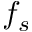<formula> <loc_0><loc_0><loc_500><loc_500>f _ { s }</formula> 